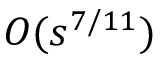Convert formula to latex. <formula><loc_0><loc_0><loc_500><loc_500>O ( s ^ { 7 / 1 1 } )</formula> 